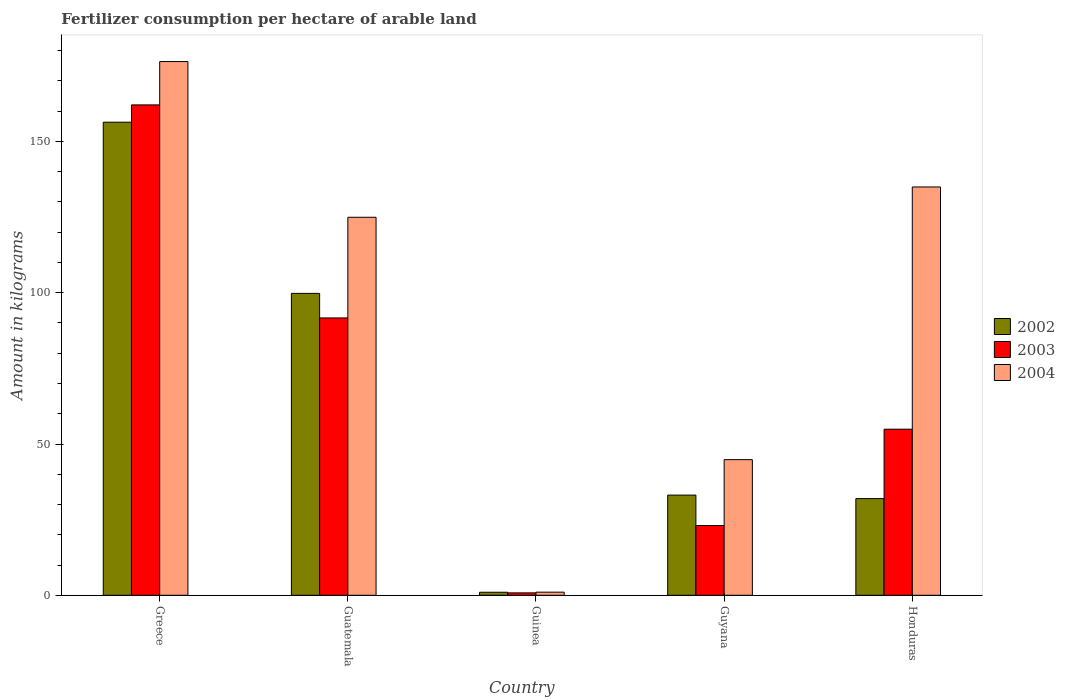What is the label of the 5th group of bars from the left?
Keep it short and to the point. Honduras. What is the amount of fertilizer consumption in 2002 in Honduras?
Make the answer very short. 31.96. Across all countries, what is the maximum amount of fertilizer consumption in 2002?
Offer a terse response. 156.38. Across all countries, what is the minimum amount of fertilizer consumption in 2003?
Provide a succinct answer. 0.79. In which country was the amount of fertilizer consumption in 2003 minimum?
Offer a very short reply. Guinea. What is the total amount of fertilizer consumption in 2004 in the graph?
Provide a succinct answer. 482.19. What is the difference between the amount of fertilizer consumption in 2002 in Greece and that in Guatemala?
Provide a succinct answer. 56.59. What is the difference between the amount of fertilizer consumption in 2004 in Guyana and the amount of fertilizer consumption in 2002 in Guinea?
Offer a very short reply. 43.83. What is the average amount of fertilizer consumption in 2002 per country?
Offer a terse response. 64.45. What is the difference between the amount of fertilizer consumption of/in 2004 and amount of fertilizer consumption of/in 2002 in Greece?
Offer a very short reply. 20.04. What is the ratio of the amount of fertilizer consumption in 2002 in Greece to that in Guyana?
Provide a succinct answer. 4.72. What is the difference between the highest and the second highest amount of fertilizer consumption in 2004?
Provide a short and direct response. 51.47. What is the difference between the highest and the lowest amount of fertilizer consumption in 2003?
Offer a very short reply. 161.3. In how many countries, is the amount of fertilizer consumption in 2004 greater than the average amount of fertilizer consumption in 2004 taken over all countries?
Make the answer very short. 3. Is the sum of the amount of fertilizer consumption in 2004 in Guinea and Guyana greater than the maximum amount of fertilizer consumption in 2003 across all countries?
Your response must be concise. No. What does the 1st bar from the left in Guatemala represents?
Give a very brief answer. 2002. What does the 1st bar from the right in Guinea represents?
Offer a very short reply. 2004. Is it the case that in every country, the sum of the amount of fertilizer consumption in 2003 and amount of fertilizer consumption in 2004 is greater than the amount of fertilizer consumption in 2002?
Make the answer very short. Yes. Are all the bars in the graph horizontal?
Your answer should be very brief. No. How many countries are there in the graph?
Make the answer very short. 5. What is the difference between two consecutive major ticks on the Y-axis?
Your response must be concise. 50. Where does the legend appear in the graph?
Provide a succinct answer. Center right. How many legend labels are there?
Provide a succinct answer. 3. How are the legend labels stacked?
Your answer should be compact. Vertical. What is the title of the graph?
Ensure brevity in your answer.  Fertilizer consumption per hectare of arable land. Does "1968" appear as one of the legend labels in the graph?
Offer a terse response. No. What is the label or title of the Y-axis?
Your answer should be very brief. Amount in kilograms. What is the Amount in kilograms in 2002 in Greece?
Offer a terse response. 156.38. What is the Amount in kilograms in 2003 in Greece?
Give a very brief answer. 162.09. What is the Amount in kilograms in 2004 in Greece?
Provide a succinct answer. 176.42. What is the Amount in kilograms in 2002 in Guatemala?
Give a very brief answer. 99.79. What is the Amount in kilograms of 2003 in Guatemala?
Keep it short and to the point. 91.67. What is the Amount in kilograms in 2004 in Guatemala?
Offer a very short reply. 124.95. What is the Amount in kilograms of 2002 in Guinea?
Give a very brief answer. 1. What is the Amount in kilograms of 2003 in Guinea?
Your response must be concise. 0.79. What is the Amount in kilograms in 2004 in Guinea?
Make the answer very short. 1.03. What is the Amount in kilograms in 2002 in Guyana?
Your answer should be very brief. 33.11. What is the Amount in kilograms of 2003 in Guyana?
Your response must be concise. 23.06. What is the Amount in kilograms of 2004 in Guyana?
Make the answer very short. 44.83. What is the Amount in kilograms in 2002 in Honduras?
Keep it short and to the point. 31.96. What is the Amount in kilograms of 2003 in Honduras?
Your response must be concise. 54.9. What is the Amount in kilograms of 2004 in Honduras?
Offer a terse response. 134.97. Across all countries, what is the maximum Amount in kilograms in 2002?
Give a very brief answer. 156.38. Across all countries, what is the maximum Amount in kilograms in 2003?
Provide a short and direct response. 162.09. Across all countries, what is the maximum Amount in kilograms of 2004?
Provide a short and direct response. 176.42. Across all countries, what is the minimum Amount in kilograms in 2002?
Your answer should be compact. 1. Across all countries, what is the minimum Amount in kilograms in 2003?
Give a very brief answer. 0.79. Across all countries, what is the minimum Amount in kilograms in 2004?
Ensure brevity in your answer.  1.03. What is the total Amount in kilograms of 2002 in the graph?
Provide a succinct answer. 322.24. What is the total Amount in kilograms in 2003 in the graph?
Provide a short and direct response. 332.51. What is the total Amount in kilograms in 2004 in the graph?
Give a very brief answer. 482.19. What is the difference between the Amount in kilograms in 2002 in Greece and that in Guatemala?
Ensure brevity in your answer.  56.59. What is the difference between the Amount in kilograms in 2003 in Greece and that in Guatemala?
Your answer should be very brief. 70.42. What is the difference between the Amount in kilograms in 2004 in Greece and that in Guatemala?
Make the answer very short. 51.47. What is the difference between the Amount in kilograms in 2002 in Greece and that in Guinea?
Offer a very short reply. 155.37. What is the difference between the Amount in kilograms of 2003 in Greece and that in Guinea?
Make the answer very short. 161.3. What is the difference between the Amount in kilograms of 2004 in Greece and that in Guinea?
Provide a succinct answer. 175.39. What is the difference between the Amount in kilograms in 2002 in Greece and that in Guyana?
Provide a short and direct response. 123.27. What is the difference between the Amount in kilograms of 2003 in Greece and that in Guyana?
Your response must be concise. 139.03. What is the difference between the Amount in kilograms in 2004 in Greece and that in Guyana?
Your response must be concise. 131.58. What is the difference between the Amount in kilograms in 2002 in Greece and that in Honduras?
Your response must be concise. 124.42. What is the difference between the Amount in kilograms of 2003 in Greece and that in Honduras?
Provide a succinct answer. 107.19. What is the difference between the Amount in kilograms in 2004 in Greece and that in Honduras?
Offer a terse response. 41.45. What is the difference between the Amount in kilograms of 2002 in Guatemala and that in Guinea?
Give a very brief answer. 98.79. What is the difference between the Amount in kilograms of 2003 in Guatemala and that in Guinea?
Your answer should be compact. 90.88. What is the difference between the Amount in kilograms of 2004 in Guatemala and that in Guinea?
Your response must be concise. 123.92. What is the difference between the Amount in kilograms in 2002 in Guatemala and that in Guyana?
Make the answer very short. 66.68. What is the difference between the Amount in kilograms in 2003 in Guatemala and that in Guyana?
Keep it short and to the point. 68.62. What is the difference between the Amount in kilograms of 2004 in Guatemala and that in Guyana?
Give a very brief answer. 80.11. What is the difference between the Amount in kilograms in 2002 in Guatemala and that in Honduras?
Your answer should be compact. 67.83. What is the difference between the Amount in kilograms of 2003 in Guatemala and that in Honduras?
Your response must be concise. 36.77. What is the difference between the Amount in kilograms of 2004 in Guatemala and that in Honduras?
Your response must be concise. -10.02. What is the difference between the Amount in kilograms in 2002 in Guinea and that in Guyana?
Offer a terse response. -32.11. What is the difference between the Amount in kilograms of 2003 in Guinea and that in Guyana?
Give a very brief answer. -22.26. What is the difference between the Amount in kilograms in 2004 in Guinea and that in Guyana?
Provide a short and direct response. -43.8. What is the difference between the Amount in kilograms of 2002 in Guinea and that in Honduras?
Give a very brief answer. -30.95. What is the difference between the Amount in kilograms of 2003 in Guinea and that in Honduras?
Your answer should be compact. -54.1. What is the difference between the Amount in kilograms of 2004 in Guinea and that in Honduras?
Provide a short and direct response. -133.94. What is the difference between the Amount in kilograms in 2002 in Guyana and that in Honduras?
Give a very brief answer. 1.15. What is the difference between the Amount in kilograms of 2003 in Guyana and that in Honduras?
Offer a very short reply. -31.84. What is the difference between the Amount in kilograms of 2004 in Guyana and that in Honduras?
Ensure brevity in your answer.  -90.13. What is the difference between the Amount in kilograms of 2002 in Greece and the Amount in kilograms of 2003 in Guatemala?
Offer a terse response. 64.71. What is the difference between the Amount in kilograms of 2002 in Greece and the Amount in kilograms of 2004 in Guatemala?
Offer a terse response. 31.43. What is the difference between the Amount in kilograms in 2003 in Greece and the Amount in kilograms in 2004 in Guatemala?
Offer a terse response. 37.14. What is the difference between the Amount in kilograms of 2002 in Greece and the Amount in kilograms of 2003 in Guinea?
Your answer should be compact. 155.58. What is the difference between the Amount in kilograms in 2002 in Greece and the Amount in kilograms in 2004 in Guinea?
Keep it short and to the point. 155.35. What is the difference between the Amount in kilograms of 2003 in Greece and the Amount in kilograms of 2004 in Guinea?
Ensure brevity in your answer.  161.06. What is the difference between the Amount in kilograms in 2002 in Greece and the Amount in kilograms in 2003 in Guyana?
Provide a short and direct response. 133.32. What is the difference between the Amount in kilograms of 2002 in Greece and the Amount in kilograms of 2004 in Guyana?
Offer a very short reply. 111.54. What is the difference between the Amount in kilograms of 2003 in Greece and the Amount in kilograms of 2004 in Guyana?
Ensure brevity in your answer.  117.26. What is the difference between the Amount in kilograms in 2002 in Greece and the Amount in kilograms in 2003 in Honduras?
Your answer should be compact. 101.48. What is the difference between the Amount in kilograms in 2002 in Greece and the Amount in kilograms in 2004 in Honduras?
Offer a terse response. 21.41. What is the difference between the Amount in kilograms of 2003 in Greece and the Amount in kilograms of 2004 in Honduras?
Make the answer very short. 27.12. What is the difference between the Amount in kilograms in 2002 in Guatemala and the Amount in kilograms in 2003 in Guinea?
Offer a very short reply. 99. What is the difference between the Amount in kilograms of 2002 in Guatemala and the Amount in kilograms of 2004 in Guinea?
Give a very brief answer. 98.76. What is the difference between the Amount in kilograms of 2003 in Guatemala and the Amount in kilograms of 2004 in Guinea?
Provide a short and direct response. 90.64. What is the difference between the Amount in kilograms of 2002 in Guatemala and the Amount in kilograms of 2003 in Guyana?
Give a very brief answer. 76.73. What is the difference between the Amount in kilograms in 2002 in Guatemala and the Amount in kilograms in 2004 in Guyana?
Your answer should be very brief. 54.96. What is the difference between the Amount in kilograms in 2003 in Guatemala and the Amount in kilograms in 2004 in Guyana?
Provide a succinct answer. 46.84. What is the difference between the Amount in kilograms in 2002 in Guatemala and the Amount in kilograms in 2003 in Honduras?
Your answer should be very brief. 44.89. What is the difference between the Amount in kilograms of 2002 in Guatemala and the Amount in kilograms of 2004 in Honduras?
Your response must be concise. -35.18. What is the difference between the Amount in kilograms of 2003 in Guatemala and the Amount in kilograms of 2004 in Honduras?
Offer a terse response. -43.29. What is the difference between the Amount in kilograms of 2002 in Guinea and the Amount in kilograms of 2003 in Guyana?
Provide a short and direct response. -22.05. What is the difference between the Amount in kilograms of 2002 in Guinea and the Amount in kilograms of 2004 in Guyana?
Your answer should be very brief. -43.83. What is the difference between the Amount in kilograms of 2003 in Guinea and the Amount in kilograms of 2004 in Guyana?
Offer a terse response. -44.04. What is the difference between the Amount in kilograms in 2002 in Guinea and the Amount in kilograms in 2003 in Honduras?
Make the answer very short. -53.89. What is the difference between the Amount in kilograms of 2002 in Guinea and the Amount in kilograms of 2004 in Honduras?
Your answer should be compact. -133.96. What is the difference between the Amount in kilograms of 2003 in Guinea and the Amount in kilograms of 2004 in Honduras?
Your answer should be compact. -134.17. What is the difference between the Amount in kilograms in 2002 in Guyana and the Amount in kilograms in 2003 in Honduras?
Keep it short and to the point. -21.79. What is the difference between the Amount in kilograms in 2002 in Guyana and the Amount in kilograms in 2004 in Honduras?
Offer a very short reply. -101.86. What is the difference between the Amount in kilograms of 2003 in Guyana and the Amount in kilograms of 2004 in Honduras?
Your answer should be compact. -111.91. What is the average Amount in kilograms of 2002 per country?
Offer a terse response. 64.45. What is the average Amount in kilograms of 2003 per country?
Offer a terse response. 66.5. What is the average Amount in kilograms in 2004 per country?
Provide a succinct answer. 96.44. What is the difference between the Amount in kilograms of 2002 and Amount in kilograms of 2003 in Greece?
Keep it short and to the point. -5.71. What is the difference between the Amount in kilograms of 2002 and Amount in kilograms of 2004 in Greece?
Your answer should be compact. -20.04. What is the difference between the Amount in kilograms of 2003 and Amount in kilograms of 2004 in Greece?
Your answer should be compact. -14.33. What is the difference between the Amount in kilograms in 2002 and Amount in kilograms in 2003 in Guatemala?
Ensure brevity in your answer.  8.12. What is the difference between the Amount in kilograms of 2002 and Amount in kilograms of 2004 in Guatemala?
Your answer should be compact. -25.16. What is the difference between the Amount in kilograms of 2003 and Amount in kilograms of 2004 in Guatemala?
Keep it short and to the point. -33.27. What is the difference between the Amount in kilograms in 2002 and Amount in kilograms in 2003 in Guinea?
Provide a short and direct response. 0.21. What is the difference between the Amount in kilograms in 2002 and Amount in kilograms in 2004 in Guinea?
Your answer should be very brief. -0.03. What is the difference between the Amount in kilograms of 2003 and Amount in kilograms of 2004 in Guinea?
Your answer should be very brief. -0.24. What is the difference between the Amount in kilograms of 2002 and Amount in kilograms of 2003 in Guyana?
Offer a very short reply. 10.06. What is the difference between the Amount in kilograms in 2002 and Amount in kilograms in 2004 in Guyana?
Provide a short and direct response. -11.72. What is the difference between the Amount in kilograms of 2003 and Amount in kilograms of 2004 in Guyana?
Offer a very short reply. -21.78. What is the difference between the Amount in kilograms of 2002 and Amount in kilograms of 2003 in Honduras?
Provide a succinct answer. -22.94. What is the difference between the Amount in kilograms of 2002 and Amount in kilograms of 2004 in Honduras?
Give a very brief answer. -103.01. What is the difference between the Amount in kilograms in 2003 and Amount in kilograms in 2004 in Honduras?
Provide a succinct answer. -80.07. What is the ratio of the Amount in kilograms in 2002 in Greece to that in Guatemala?
Offer a terse response. 1.57. What is the ratio of the Amount in kilograms in 2003 in Greece to that in Guatemala?
Give a very brief answer. 1.77. What is the ratio of the Amount in kilograms of 2004 in Greece to that in Guatemala?
Ensure brevity in your answer.  1.41. What is the ratio of the Amount in kilograms in 2002 in Greece to that in Guinea?
Your response must be concise. 155.73. What is the ratio of the Amount in kilograms of 2003 in Greece to that in Guinea?
Provide a short and direct response. 204.16. What is the ratio of the Amount in kilograms in 2004 in Greece to that in Guinea?
Ensure brevity in your answer.  171.25. What is the ratio of the Amount in kilograms in 2002 in Greece to that in Guyana?
Your response must be concise. 4.72. What is the ratio of the Amount in kilograms of 2003 in Greece to that in Guyana?
Make the answer very short. 7.03. What is the ratio of the Amount in kilograms in 2004 in Greece to that in Guyana?
Provide a succinct answer. 3.94. What is the ratio of the Amount in kilograms of 2002 in Greece to that in Honduras?
Offer a very short reply. 4.89. What is the ratio of the Amount in kilograms in 2003 in Greece to that in Honduras?
Your answer should be compact. 2.95. What is the ratio of the Amount in kilograms of 2004 in Greece to that in Honduras?
Offer a very short reply. 1.31. What is the ratio of the Amount in kilograms in 2002 in Guatemala to that in Guinea?
Your answer should be compact. 99.37. What is the ratio of the Amount in kilograms of 2003 in Guatemala to that in Guinea?
Provide a short and direct response. 115.46. What is the ratio of the Amount in kilograms in 2004 in Guatemala to that in Guinea?
Make the answer very short. 121.28. What is the ratio of the Amount in kilograms in 2002 in Guatemala to that in Guyana?
Give a very brief answer. 3.01. What is the ratio of the Amount in kilograms in 2003 in Guatemala to that in Guyana?
Ensure brevity in your answer.  3.98. What is the ratio of the Amount in kilograms in 2004 in Guatemala to that in Guyana?
Make the answer very short. 2.79. What is the ratio of the Amount in kilograms in 2002 in Guatemala to that in Honduras?
Your answer should be compact. 3.12. What is the ratio of the Amount in kilograms in 2003 in Guatemala to that in Honduras?
Your answer should be compact. 1.67. What is the ratio of the Amount in kilograms of 2004 in Guatemala to that in Honduras?
Give a very brief answer. 0.93. What is the ratio of the Amount in kilograms of 2002 in Guinea to that in Guyana?
Offer a terse response. 0.03. What is the ratio of the Amount in kilograms in 2003 in Guinea to that in Guyana?
Ensure brevity in your answer.  0.03. What is the ratio of the Amount in kilograms in 2004 in Guinea to that in Guyana?
Your response must be concise. 0.02. What is the ratio of the Amount in kilograms of 2002 in Guinea to that in Honduras?
Make the answer very short. 0.03. What is the ratio of the Amount in kilograms in 2003 in Guinea to that in Honduras?
Your response must be concise. 0.01. What is the ratio of the Amount in kilograms of 2004 in Guinea to that in Honduras?
Make the answer very short. 0.01. What is the ratio of the Amount in kilograms of 2002 in Guyana to that in Honduras?
Your answer should be compact. 1.04. What is the ratio of the Amount in kilograms in 2003 in Guyana to that in Honduras?
Ensure brevity in your answer.  0.42. What is the ratio of the Amount in kilograms in 2004 in Guyana to that in Honduras?
Provide a succinct answer. 0.33. What is the difference between the highest and the second highest Amount in kilograms of 2002?
Give a very brief answer. 56.59. What is the difference between the highest and the second highest Amount in kilograms of 2003?
Offer a terse response. 70.42. What is the difference between the highest and the second highest Amount in kilograms in 2004?
Give a very brief answer. 41.45. What is the difference between the highest and the lowest Amount in kilograms of 2002?
Keep it short and to the point. 155.37. What is the difference between the highest and the lowest Amount in kilograms of 2003?
Offer a very short reply. 161.3. What is the difference between the highest and the lowest Amount in kilograms of 2004?
Your answer should be compact. 175.39. 